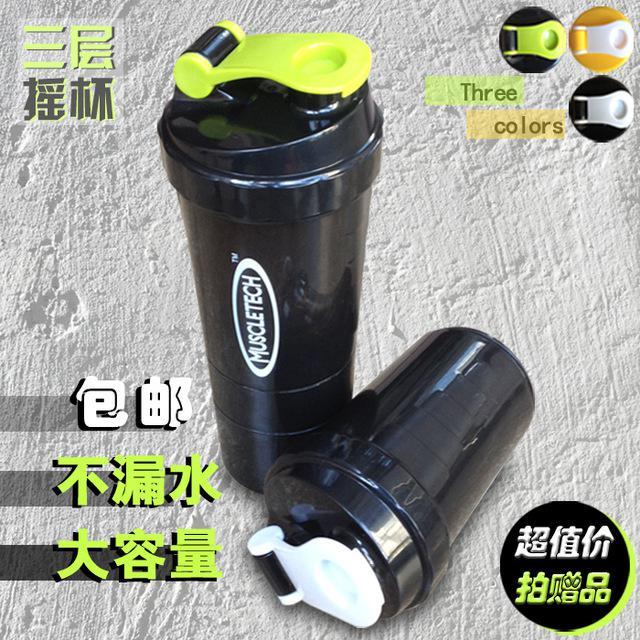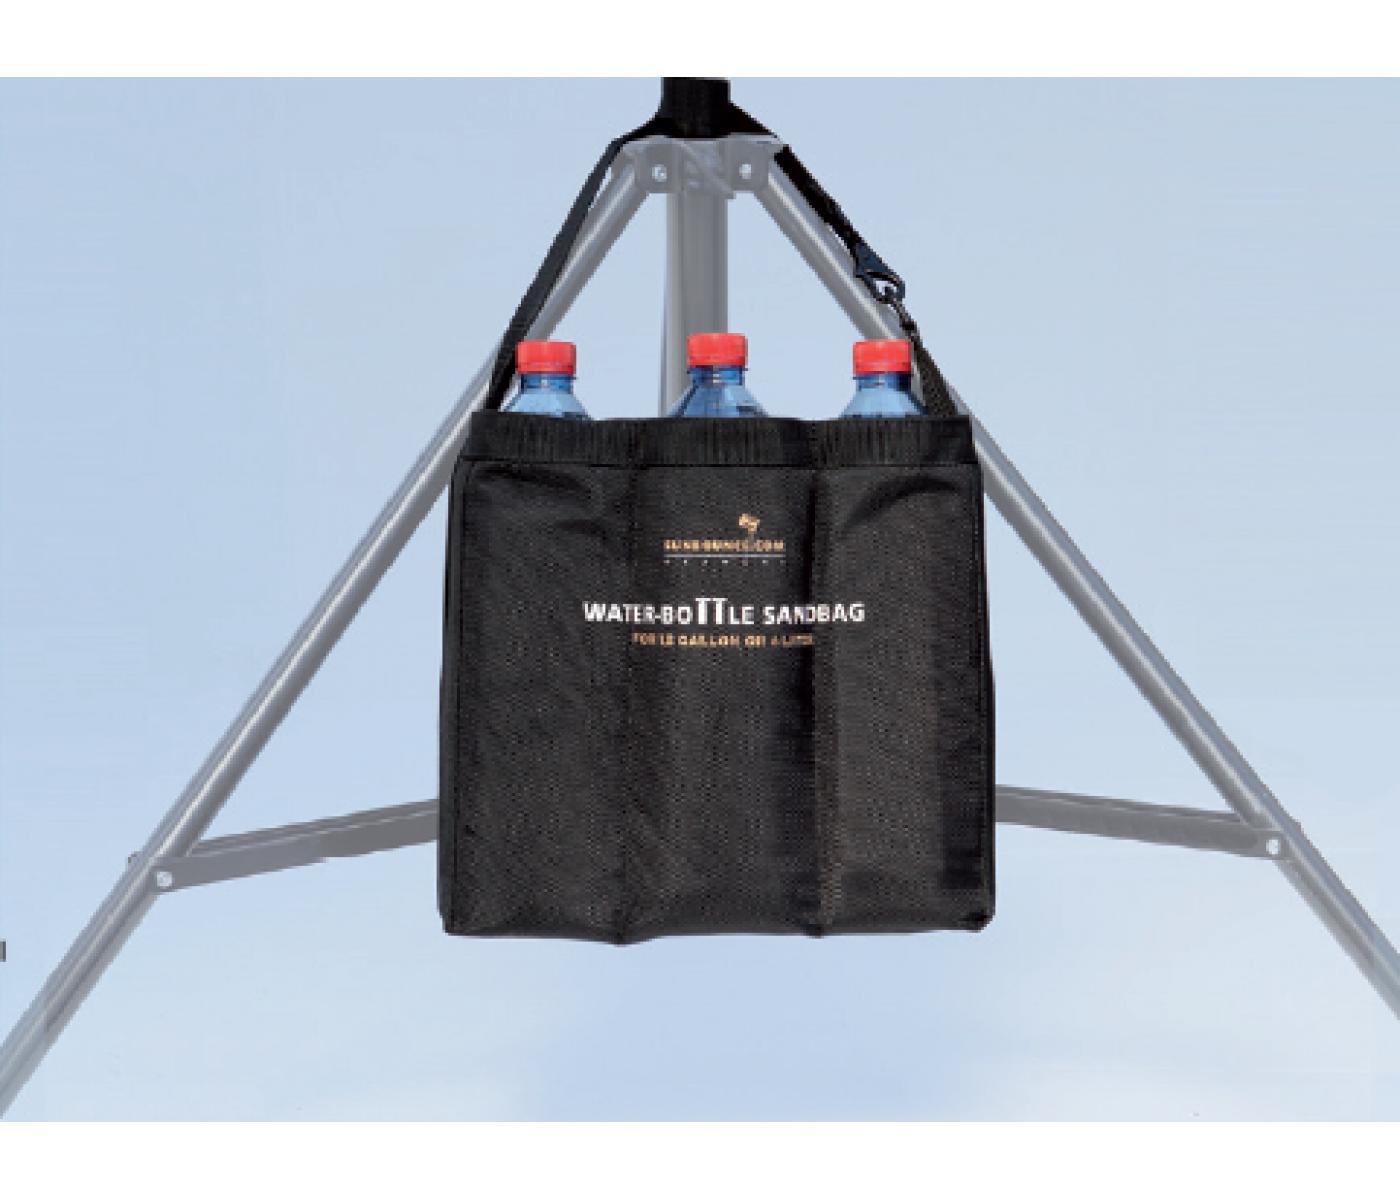The first image is the image on the left, the second image is the image on the right. Analyze the images presented: Is the assertion "in the image on the left, there is at least 3 containers visible." valid? Answer yes or no. No. The first image is the image on the left, the second image is the image on the right. For the images displayed, is the sentence "There is a total of 1 pouch that holds 3 plastic bottles." factually correct? Answer yes or no. Yes. 